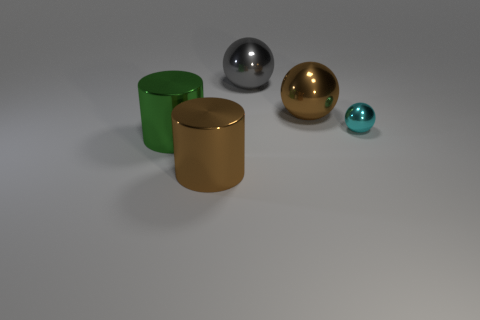There is another object that is the same shape as the green shiny thing; what size is it?
Your answer should be very brief. Large. Does the large cylinder in front of the large green metallic cylinder have the same material as the brown object behind the cyan metal ball?
Offer a very short reply. Yes. What number of rubber objects are cyan balls or large gray spheres?
Your answer should be very brief. 0. What material is the big brown cylinder that is in front of the large metal sphere that is behind the large thing that is on the right side of the big gray shiny ball made of?
Your response must be concise. Metal. There is a brown shiny thing right of the gray shiny sphere; does it have the same shape as the brown object that is in front of the small cyan ball?
Keep it short and to the point. No. What color is the large shiny cylinder right of the big shiny object left of the large brown cylinder?
Offer a terse response. Brown. What number of blocks are large gray metal objects or large blue metal things?
Your response must be concise. 0. There is a small object that is to the right of the shiny object on the left side of the big brown cylinder; what number of brown objects are in front of it?
Keep it short and to the point. 1. Are there any tiny purple cubes that have the same material as the big brown ball?
Offer a terse response. No. Is the material of the big green cylinder the same as the big brown cylinder?
Give a very brief answer. Yes. 